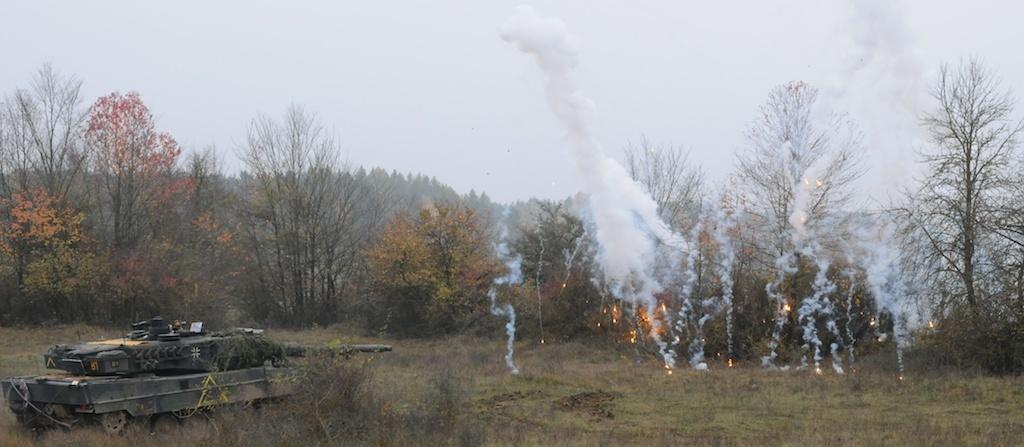What type of vehicle is in the image? There is a vehicle in the image, but the specific type is not mentioned in the facts. What is the natural environment like in the image? The image features grass, plants, trees, and the sky, which suggests a natural setting. What is happening with the fire and smoke in the image? The presence of fire and smoke in the image indicates that something is burning. Can you describe the sky in the image? The sky is visible in the background of the image, but no specific details about its appearance are provided in the facts. What type of soup is being served in the image? There is no soup present in the image; it features a vehicle, grass, plants, fire, smoke, trees, and the sky. How many bells can be heard ringing in the image? There are no bells mentioned or depicted in the image. 